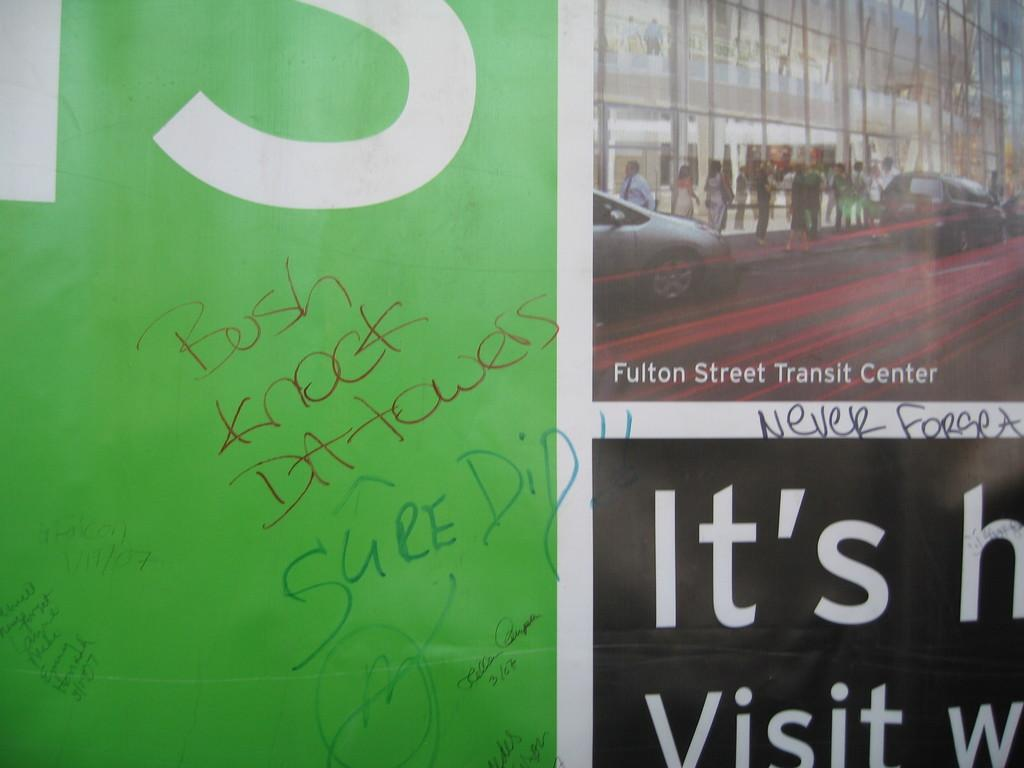What is hanging in the picture? There is a banner in the picture. What can be found on the banner? There is text and a picture of a group of people on the banner. What else is visible in the picture besides the banner? There are vehicles and a building in the picture. What type of quilt is being used to cover the vehicles in the picture? There is no quilt present in the image, and the vehicles are not covered. What color is the silver object on the banner? There is no silver object present on the banner; it only has text and a picture of a group of people. 